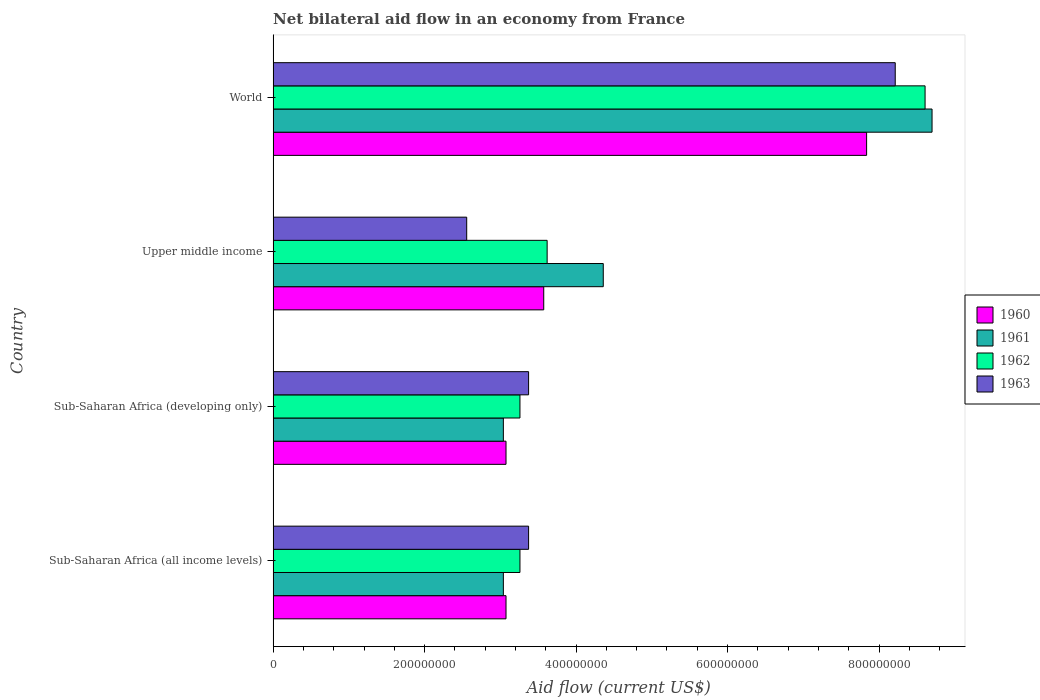How many groups of bars are there?
Offer a very short reply. 4. Are the number of bars per tick equal to the number of legend labels?
Offer a terse response. Yes. How many bars are there on the 4th tick from the bottom?
Ensure brevity in your answer.  4. What is the label of the 1st group of bars from the top?
Your answer should be very brief. World. In how many cases, is the number of bars for a given country not equal to the number of legend labels?
Your response must be concise. 0. What is the net bilateral aid flow in 1963 in Sub-Saharan Africa (all income levels)?
Your answer should be compact. 3.37e+08. Across all countries, what is the maximum net bilateral aid flow in 1962?
Ensure brevity in your answer.  8.61e+08. Across all countries, what is the minimum net bilateral aid flow in 1963?
Your answer should be very brief. 2.56e+08. In which country was the net bilateral aid flow in 1960 minimum?
Keep it short and to the point. Sub-Saharan Africa (all income levels). What is the total net bilateral aid flow in 1961 in the graph?
Your response must be concise. 1.91e+09. What is the difference between the net bilateral aid flow in 1960 in Sub-Saharan Africa (all income levels) and that in Upper middle income?
Your answer should be very brief. -4.98e+07. What is the difference between the net bilateral aid flow in 1963 in World and the net bilateral aid flow in 1960 in Upper middle income?
Make the answer very short. 4.64e+08. What is the average net bilateral aid flow in 1961 per country?
Your answer should be very brief. 4.78e+08. What is the difference between the net bilateral aid flow in 1963 and net bilateral aid flow in 1960 in World?
Give a very brief answer. 3.78e+07. In how many countries, is the net bilateral aid flow in 1960 greater than 200000000 US$?
Your answer should be compact. 4. What is the ratio of the net bilateral aid flow in 1962 in Upper middle income to that in World?
Your answer should be compact. 0.42. Is the net bilateral aid flow in 1963 in Sub-Saharan Africa (developing only) less than that in World?
Provide a short and direct response. Yes. What is the difference between the highest and the second highest net bilateral aid flow in 1963?
Provide a short and direct response. 4.84e+08. What is the difference between the highest and the lowest net bilateral aid flow in 1962?
Provide a succinct answer. 5.35e+08. Is the sum of the net bilateral aid flow in 1960 in Upper middle income and World greater than the maximum net bilateral aid flow in 1963 across all countries?
Provide a succinct answer. Yes. What does the 1st bar from the top in Upper middle income represents?
Ensure brevity in your answer.  1963. Are all the bars in the graph horizontal?
Provide a short and direct response. Yes. How many countries are there in the graph?
Offer a very short reply. 4. What is the difference between two consecutive major ticks on the X-axis?
Your answer should be very brief. 2.00e+08. Does the graph contain any zero values?
Make the answer very short. No. How many legend labels are there?
Give a very brief answer. 4. What is the title of the graph?
Your response must be concise. Net bilateral aid flow in an economy from France. Does "1993" appear as one of the legend labels in the graph?
Provide a succinct answer. No. What is the label or title of the Y-axis?
Keep it short and to the point. Country. What is the Aid flow (current US$) in 1960 in Sub-Saharan Africa (all income levels)?
Make the answer very short. 3.08e+08. What is the Aid flow (current US$) of 1961 in Sub-Saharan Africa (all income levels)?
Your answer should be compact. 3.04e+08. What is the Aid flow (current US$) in 1962 in Sub-Saharan Africa (all income levels)?
Provide a succinct answer. 3.26e+08. What is the Aid flow (current US$) in 1963 in Sub-Saharan Africa (all income levels)?
Provide a succinct answer. 3.37e+08. What is the Aid flow (current US$) of 1960 in Sub-Saharan Africa (developing only)?
Offer a very short reply. 3.08e+08. What is the Aid flow (current US$) of 1961 in Sub-Saharan Africa (developing only)?
Make the answer very short. 3.04e+08. What is the Aid flow (current US$) in 1962 in Sub-Saharan Africa (developing only)?
Offer a very short reply. 3.26e+08. What is the Aid flow (current US$) of 1963 in Sub-Saharan Africa (developing only)?
Your answer should be compact. 3.37e+08. What is the Aid flow (current US$) of 1960 in Upper middle income?
Provide a succinct answer. 3.57e+08. What is the Aid flow (current US$) in 1961 in Upper middle income?
Provide a succinct answer. 4.36e+08. What is the Aid flow (current US$) in 1962 in Upper middle income?
Your answer should be very brief. 3.62e+08. What is the Aid flow (current US$) of 1963 in Upper middle income?
Your answer should be compact. 2.56e+08. What is the Aid flow (current US$) of 1960 in World?
Ensure brevity in your answer.  7.84e+08. What is the Aid flow (current US$) in 1961 in World?
Make the answer very short. 8.70e+08. What is the Aid flow (current US$) of 1962 in World?
Keep it short and to the point. 8.61e+08. What is the Aid flow (current US$) in 1963 in World?
Offer a very short reply. 8.21e+08. Across all countries, what is the maximum Aid flow (current US$) in 1960?
Your answer should be very brief. 7.84e+08. Across all countries, what is the maximum Aid flow (current US$) in 1961?
Your answer should be very brief. 8.70e+08. Across all countries, what is the maximum Aid flow (current US$) in 1962?
Your answer should be very brief. 8.61e+08. Across all countries, what is the maximum Aid flow (current US$) in 1963?
Keep it short and to the point. 8.21e+08. Across all countries, what is the minimum Aid flow (current US$) of 1960?
Keep it short and to the point. 3.08e+08. Across all countries, what is the minimum Aid flow (current US$) in 1961?
Provide a short and direct response. 3.04e+08. Across all countries, what is the minimum Aid flow (current US$) of 1962?
Offer a very short reply. 3.26e+08. Across all countries, what is the minimum Aid flow (current US$) in 1963?
Offer a terse response. 2.56e+08. What is the total Aid flow (current US$) in 1960 in the graph?
Your response must be concise. 1.76e+09. What is the total Aid flow (current US$) of 1961 in the graph?
Ensure brevity in your answer.  1.91e+09. What is the total Aid flow (current US$) in 1962 in the graph?
Your answer should be very brief. 1.87e+09. What is the total Aid flow (current US$) of 1963 in the graph?
Provide a succinct answer. 1.75e+09. What is the difference between the Aid flow (current US$) of 1961 in Sub-Saharan Africa (all income levels) and that in Sub-Saharan Africa (developing only)?
Your answer should be compact. 0. What is the difference between the Aid flow (current US$) in 1960 in Sub-Saharan Africa (all income levels) and that in Upper middle income?
Give a very brief answer. -4.98e+07. What is the difference between the Aid flow (current US$) of 1961 in Sub-Saharan Africa (all income levels) and that in Upper middle income?
Make the answer very short. -1.32e+08. What is the difference between the Aid flow (current US$) of 1962 in Sub-Saharan Africa (all income levels) and that in Upper middle income?
Provide a short and direct response. -3.59e+07. What is the difference between the Aid flow (current US$) in 1963 in Sub-Saharan Africa (all income levels) and that in Upper middle income?
Offer a terse response. 8.17e+07. What is the difference between the Aid flow (current US$) of 1960 in Sub-Saharan Africa (all income levels) and that in World?
Ensure brevity in your answer.  -4.76e+08. What is the difference between the Aid flow (current US$) of 1961 in Sub-Saharan Africa (all income levels) and that in World?
Give a very brief answer. -5.66e+08. What is the difference between the Aid flow (current US$) in 1962 in Sub-Saharan Africa (all income levels) and that in World?
Your response must be concise. -5.35e+08. What is the difference between the Aid flow (current US$) in 1963 in Sub-Saharan Africa (all income levels) and that in World?
Provide a succinct answer. -4.84e+08. What is the difference between the Aid flow (current US$) of 1960 in Sub-Saharan Africa (developing only) and that in Upper middle income?
Provide a short and direct response. -4.98e+07. What is the difference between the Aid flow (current US$) in 1961 in Sub-Saharan Africa (developing only) and that in Upper middle income?
Your answer should be compact. -1.32e+08. What is the difference between the Aid flow (current US$) of 1962 in Sub-Saharan Africa (developing only) and that in Upper middle income?
Offer a terse response. -3.59e+07. What is the difference between the Aid flow (current US$) of 1963 in Sub-Saharan Africa (developing only) and that in Upper middle income?
Offer a terse response. 8.17e+07. What is the difference between the Aid flow (current US$) in 1960 in Sub-Saharan Africa (developing only) and that in World?
Offer a very short reply. -4.76e+08. What is the difference between the Aid flow (current US$) of 1961 in Sub-Saharan Africa (developing only) and that in World?
Offer a very short reply. -5.66e+08. What is the difference between the Aid flow (current US$) in 1962 in Sub-Saharan Africa (developing only) and that in World?
Provide a short and direct response. -5.35e+08. What is the difference between the Aid flow (current US$) of 1963 in Sub-Saharan Africa (developing only) and that in World?
Your answer should be compact. -4.84e+08. What is the difference between the Aid flow (current US$) of 1960 in Upper middle income and that in World?
Ensure brevity in your answer.  -4.26e+08. What is the difference between the Aid flow (current US$) of 1961 in Upper middle income and that in World?
Offer a very short reply. -4.34e+08. What is the difference between the Aid flow (current US$) of 1962 in Upper middle income and that in World?
Give a very brief answer. -4.99e+08. What is the difference between the Aid flow (current US$) of 1963 in Upper middle income and that in World?
Ensure brevity in your answer.  -5.66e+08. What is the difference between the Aid flow (current US$) in 1960 in Sub-Saharan Africa (all income levels) and the Aid flow (current US$) in 1961 in Sub-Saharan Africa (developing only)?
Provide a succinct answer. 3.50e+06. What is the difference between the Aid flow (current US$) in 1960 in Sub-Saharan Africa (all income levels) and the Aid flow (current US$) in 1962 in Sub-Saharan Africa (developing only)?
Your answer should be compact. -1.84e+07. What is the difference between the Aid flow (current US$) of 1960 in Sub-Saharan Africa (all income levels) and the Aid flow (current US$) of 1963 in Sub-Saharan Africa (developing only)?
Offer a terse response. -2.98e+07. What is the difference between the Aid flow (current US$) of 1961 in Sub-Saharan Africa (all income levels) and the Aid flow (current US$) of 1962 in Sub-Saharan Africa (developing only)?
Offer a very short reply. -2.19e+07. What is the difference between the Aid flow (current US$) of 1961 in Sub-Saharan Africa (all income levels) and the Aid flow (current US$) of 1963 in Sub-Saharan Africa (developing only)?
Give a very brief answer. -3.33e+07. What is the difference between the Aid flow (current US$) of 1962 in Sub-Saharan Africa (all income levels) and the Aid flow (current US$) of 1963 in Sub-Saharan Africa (developing only)?
Give a very brief answer. -1.14e+07. What is the difference between the Aid flow (current US$) of 1960 in Sub-Saharan Africa (all income levels) and the Aid flow (current US$) of 1961 in Upper middle income?
Ensure brevity in your answer.  -1.28e+08. What is the difference between the Aid flow (current US$) in 1960 in Sub-Saharan Africa (all income levels) and the Aid flow (current US$) in 1962 in Upper middle income?
Make the answer very short. -5.43e+07. What is the difference between the Aid flow (current US$) in 1960 in Sub-Saharan Africa (all income levels) and the Aid flow (current US$) in 1963 in Upper middle income?
Offer a terse response. 5.19e+07. What is the difference between the Aid flow (current US$) in 1961 in Sub-Saharan Africa (all income levels) and the Aid flow (current US$) in 1962 in Upper middle income?
Your answer should be compact. -5.78e+07. What is the difference between the Aid flow (current US$) of 1961 in Sub-Saharan Africa (all income levels) and the Aid flow (current US$) of 1963 in Upper middle income?
Give a very brief answer. 4.84e+07. What is the difference between the Aid flow (current US$) of 1962 in Sub-Saharan Africa (all income levels) and the Aid flow (current US$) of 1963 in Upper middle income?
Your answer should be compact. 7.03e+07. What is the difference between the Aid flow (current US$) of 1960 in Sub-Saharan Africa (all income levels) and the Aid flow (current US$) of 1961 in World?
Your answer should be very brief. -5.62e+08. What is the difference between the Aid flow (current US$) of 1960 in Sub-Saharan Africa (all income levels) and the Aid flow (current US$) of 1962 in World?
Keep it short and to the point. -5.53e+08. What is the difference between the Aid flow (current US$) in 1960 in Sub-Saharan Africa (all income levels) and the Aid flow (current US$) in 1963 in World?
Offer a terse response. -5.14e+08. What is the difference between the Aid flow (current US$) in 1961 in Sub-Saharan Africa (all income levels) and the Aid flow (current US$) in 1962 in World?
Ensure brevity in your answer.  -5.57e+08. What is the difference between the Aid flow (current US$) of 1961 in Sub-Saharan Africa (all income levels) and the Aid flow (current US$) of 1963 in World?
Your response must be concise. -5.17e+08. What is the difference between the Aid flow (current US$) in 1962 in Sub-Saharan Africa (all income levels) and the Aid flow (current US$) in 1963 in World?
Ensure brevity in your answer.  -4.96e+08. What is the difference between the Aid flow (current US$) in 1960 in Sub-Saharan Africa (developing only) and the Aid flow (current US$) in 1961 in Upper middle income?
Offer a terse response. -1.28e+08. What is the difference between the Aid flow (current US$) in 1960 in Sub-Saharan Africa (developing only) and the Aid flow (current US$) in 1962 in Upper middle income?
Your answer should be very brief. -5.43e+07. What is the difference between the Aid flow (current US$) in 1960 in Sub-Saharan Africa (developing only) and the Aid flow (current US$) in 1963 in Upper middle income?
Make the answer very short. 5.19e+07. What is the difference between the Aid flow (current US$) of 1961 in Sub-Saharan Africa (developing only) and the Aid flow (current US$) of 1962 in Upper middle income?
Your response must be concise. -5.78e+07. What is the difference between the Aid flow (current US$) of 1961 in Sub-Saharan Africa (developing only) and the Aid flow (current US$) of 1963 in Upper middle income?
Offer a terse response. 4.84e+07. What is the difference between the Aid flow (current US$) in 1962 in Sub-Saharan Africa (developing only) and the Aid flow (current US$) in 1963 in Upper middle income?
Ensure brevity in your answer.  7.03e+07. What is the difference between the Aid flow (current US$) of 1960 in Sub-Saharan Africa (developing only) and the Aid flow (current US$) of 1961 in World?
Make the answer very short. -5.62e+08. What is the difference between the Aid flow (current US$) of 1960 in Sub-Saharan Africa (developing only) and the Aid flow (current US$) of 1962 in World?
Provide a short and direct response. -5.53e+08. What is the difference between the Aid flow (current US$) in 1960 in Sub-Saharan Africa (developing only) and the Aid flow (current US$) in 1963 in World?
Offer a terse response. -5.14e+08. What is the difference between the Aid flow (current US$) of 1961 in Sub-Saharan Africa (developing only) and the Aid flow (current US$) of 1962 in World?
Your answer should be very brief. -5.57e+08. What is the difference between the Aid flow (current US$) in 1961 in Sub-Saharan Africa (developing only) and the Aid flow (current US$) in 1963 in World?
Keep it short and to the point. -5.17e+08. What is the difference between the Aid flow (current US$) of 1962 in Sub-Saharan Africa (developing only) and the Aid flow (current US$) of 1963 in World?
Provide a succinct answer. -4.96e+08. What is the difference between the Aid flow (current US$) of 1960 in Upper middle income and the Aid flow (current US$) of 1961 in World?
Offer a terse response. -5.13e+08. What is the difference between the Aid flow (current US$) of 1960 in Upper middle income and the Aid flow (current US$) of 1962 in World?
Ensure brevity in your answer.  -5.04e+08. What is the difference between the Aid flow (current US$) of 1960 in Upper middle income and the Aid flow (current US$) of 1963 in World?
Make the answer very short. -4.64e+08. What is the difference between the Aid flow (current US$) of 1961 in Upper middle income and the Aid flow (current US$) of 1962 in World?
Your answer should be very brief. -4.25e+08. What is the difference between the Aid flow (current US$) in 1961 in Upper middle income and the Aid flow (current US$) in 1963 in World?
Keep it short and to the point. -3.86e+08. What is the difference between the Aid flow (current US$) of 1962 in Upper middle income and the Aid flow (current US$) of 1963 in World?
Keep it short and to the point. -4.60e+08. What is the average Aid flow (current US$) in 1960 per country?
Your answer should be compact. 4.39e+08. What is the average Aid flow (current US$) in 1961 per country?
Offer a very short reply. 4.78e+08. What is the average Aid flow (current US$) of 1962 per country?
Your response must be concise. 4.69e+08. What is the average Aid flow (current US$) of 1963 per country?
Provide a succinct answer. 4.38e+08. What is the difference between the Aid flow (current US$) in 1960 and Aid flow (current US$) in 1961 in Sub-Saharan Africa (all income levels)?
Your answer should be very brief. 3.50e+06. What is the difference between the Aid flow (current US$) in 1960 and Aid flow (current US$) in 1962 in Sub-Saharan Africa (all income levels)?
Ensure brevity in your answer.  -1.84e+07. What is the difference between the Aid flow (current US$) of 1960 and Aid flow (current US$) of 1963 in Sub-Saharan Africa (all income levels)?
Ensure brevity in your answer.  -2.98e+07. What is the difference between the Aid flow (current US$) in 1961 and Aid flow (current US$) in 1962 in Sub-Saharan Africa (all income levels)?
Ensure brevity in your answer.  -2.19e+07. What is the difference between the Aid flow (current US$) of 1961 and Aid flow (current US$) of 1963 in Sub-Saharan Africa (all income levels)?
Offer a terse response. -3.33e+07. What is the difference between the Aid flow (current US$) of 1962 and Aid flow (current US$) of 1963 in Sub-Saharan Africa (all income levels)?
Make the answer very short. -1.14e+07. What is the difference between the Aid flow (current US$) in 1960 and Aid flow (current US$) in 1961 in Sub-Saharan Africa (developing only)?
Your answer should be compact. 3.50e+06. What is the difference between the Aid flow (current US$) of 1960 and Aid flow (current US$) of 1962 in Sub-Saharan Africa (developing only)?
Provide a succinct answer. -1.84e+07. What is the difference between the Aid flow (current US$) of 1960 and Aid flow (current US$) of 1963 in Sub-Saharan Africa (developing only)?
Make the answer very short. -2.98e+07. What is the difference between the Aid flow (current US$) in 1961 and Aid flow (current US$) in 1962 in Sub-Saharan Africa (developing only)?
Your response must be concise. -2.19e+07. What is the difference between the Aid flow (current US$) of 1961 and Aid flow (current US$) of 1963 in Sub-Saharan Africa (developing only)?
Your response must be concise. -3.33e+07. What is the difference between the Aid flow (current US$) of 1962 and Aid flow (current US$) of 1963 in Sub-Saharan Africa (developing only)?
Offer a terse response. -1.14e+07. What is the difference between the Aid flow (current US$) in 1960 and Aid flow (current US$) in 1961 in Upper middle income?
Offer a very short reply. -7.86e+07. What is the difference between the Aid flow (current US$) of 1960 and Aid flow (current US$) of 1962 in Upper middle income?
Your response must be concise. -4.50e+06. What is the difference between the Aid flow (current US$) of 1960 and Aid flow (current US$) of 1963 in Upper middle income?
Offer a very short reply. 1.02e+08. What is the difference between the Aid flow (current US$) in 1961 and Aid flow (current US$) in 1962 in Upper middle income?
Give a very brief answer. 7.41e+07. What is the difference between the Aid flow (current US$) in 1961 and Aid flow (current US$) in 1963 in Upper middle income?
Keep it short and to the point. 1.80e+08. What is the difference between the Aid flow (current US$) in 1962 and Aid flow (current US$) in 1963 in Upper middle income?
Ensure brevity in your answer.  1.06e+08. What is the difference between the Aid flow (current US$) in 1960 and Aid flow (current US$) in 1961 in World?
Your response must be concise. -8.64e+07. What is the difference between the Aid flow (current US$) in 1960 and Aid flow (current US$) in 1962 in World?
Provide a short and direct response. -7.72e+07. What is the difference between the Aid flow (current US$) in 1960 and Aid flow (current US$) in 1963 in World?
Offer a very short reply. -3.78e+07. What is the difference between the Aid flow (current US$) of 1961 and Aid flow (current US$) of 1962 in World?
Provide a succinct answer. 9.20e+06. What is the difference between the Aid flow (current US$) of 1961 and Aid flow (current US$) of 1963 in World?
Offer a terse response. 4.86e+07. What is the difference between the Aid flow (current US$) of 1962 and Aid flow (current US$) of 1963 in World?
Offer a very short reply. 3.94e+07. What is the ratio of the Aid flow (current US$) of 1961 in Sub-Saharan Africa (all income levels) to that in Sub-Saharan Africa (developing only)?
Provide a succinct answer. 1. What is the ratio of the Aid flow (current US$) in 1962 in Sub-Saharan Africa (all income levels) to that in Sub-Saharan Africa (developing only)?
Offer a terse response. 1. What is the ratio of the Aid flow (current US$) of 1960 in Sub-Saharan Africa (all income levels) to that in Upper middle income?
Keep it short and to the point. 0.86. What is the ratio of the Aid flow (current US$) of 1961 in Sub-Saharan Africa (all income levels) to that in Upper middle income?
Offer a very short reply. 0.7. What is the ratio of the Aid flow (current US$) in 1962 in Sub-Saharan Africa (all income levels) to that in Upper middle income?
Ensure brevity in your answer.  0.9. What is the ratio of the Aid flow (current US$) of 1963 in Sub-Saharan Africa (all income levels) to that in Upper middle income?
Your answer should be compact. 1.32. What is the ratio of the Aid flow (current US$) of 1960 in Sub-Saharan Africa (all income levels) to that in World?
Make the answer very short. 0.39. What is the ratio of the Aid flow (current US$) in 1961 in Sub-Saharan Africa (all income levels) to that in World?
Your answer should be compact. 0.35. What is the ratio of the Aid flow (current US$) of 1962 in Sub-Saharan Africa (all income levels) to that in World?
Give a very brief answer. 0.38. What is the ratio of the Aid flow (current US$) of 1963 in Sub-Saharan Africa (all income levels) to that in World?
Make the answer very short. 0.41. What is the ratio of the Aid flow (current US$) of 1960 in Sub-Saharan Africa (developing only) to that in Upper middle income?
Provide a succinct answer. 0.86. What is the ratio of the Aid flow (current US$) of 1961 in Sub-Saharan Africa (developing only) to that in Upper middle income?
Offer a very short reply. 0.7. What is the ratio of the Aid flow (current US$) of 1962 in Sub-Saharan Africa (developing only) to that in Upper middle income?
Your answer should be very brief. 0.9. What is the ratio of the Aid flow (current US$) of 1963 in Sub-Saharan Africa (developing only) to that in Upper middle income?
Your answer should be very brief. 1.32. What is the ratio of the Aid flow (current US$) in 1960 in Sub-Saharan Africa (developing only) to that in World?
Offer a very short reply. 0.39. What is the ratio of the Aid flow (current US$) in 1961 in Sub-Saharan Africa (developing only) to that in World?
Provide a succinct answer. 0.35. What is the ratio of the Aid flow (current US$) of 1962 in Sub-Saharan Africa (developing only) to that in World?
Your response must be concise. 0.38. What is the ratio of the Aid flow (current US$) of 1963 in Sub-Saharan Africa (developing only) to that in World?
Your answer should be very brief. 0.41. What is the ratio of the Aid flow (current US$) of 1960 in Upper middle income to that in World?
Your answer should be very brief. 0.46. What is the ratio of the Aid flow (current US$) of 1961 in Upper middle income to that in World?
Your answer should be very brief. 0.5. What is the ratio of the Aid flow (current US$) in 1962 in Upper middle income to that in World?
Provide a succinct answer. 0.42. What is the ratio of the Aid flow (current US$) of 1963 in Upper middle income to that in World?
Make the answer very short. 0.31. What is the difference between the highest and the second highest Aid flow (current US$) of 1960?
Keep it short and to the point. 4.26e+08. What is the difference between the highest and the second highest Aid flow (current US$) of 1961?
Your response must be concise. 4.34e+08. What is the difference between the highest and the second highest Aid flow (current US$) of 1962?
Offer a very short reply. 4.99e+08. What is the difference between the highest and the second highest Aid flow (current US$) in 1963?
Ensure brevity in your answer.  4.84e+08. What is the difference between the highest and the lowest Aid flow (current US$) of 1960?
Offer a very short reply. 4.76e+08. What is the difference between the highest and the lowest Aid flow (current US$) in 1961?
Provide a short and direct response. 5.66e+08. What is the difference between the highest and the lowest Aid flow (current US$) in 1962?
Your response must be concise. 5.35e+08. What is the difference between the highest and the lowest Aid flow (current US$) of 1963?
Make the answer very short. 5.66e+08. 